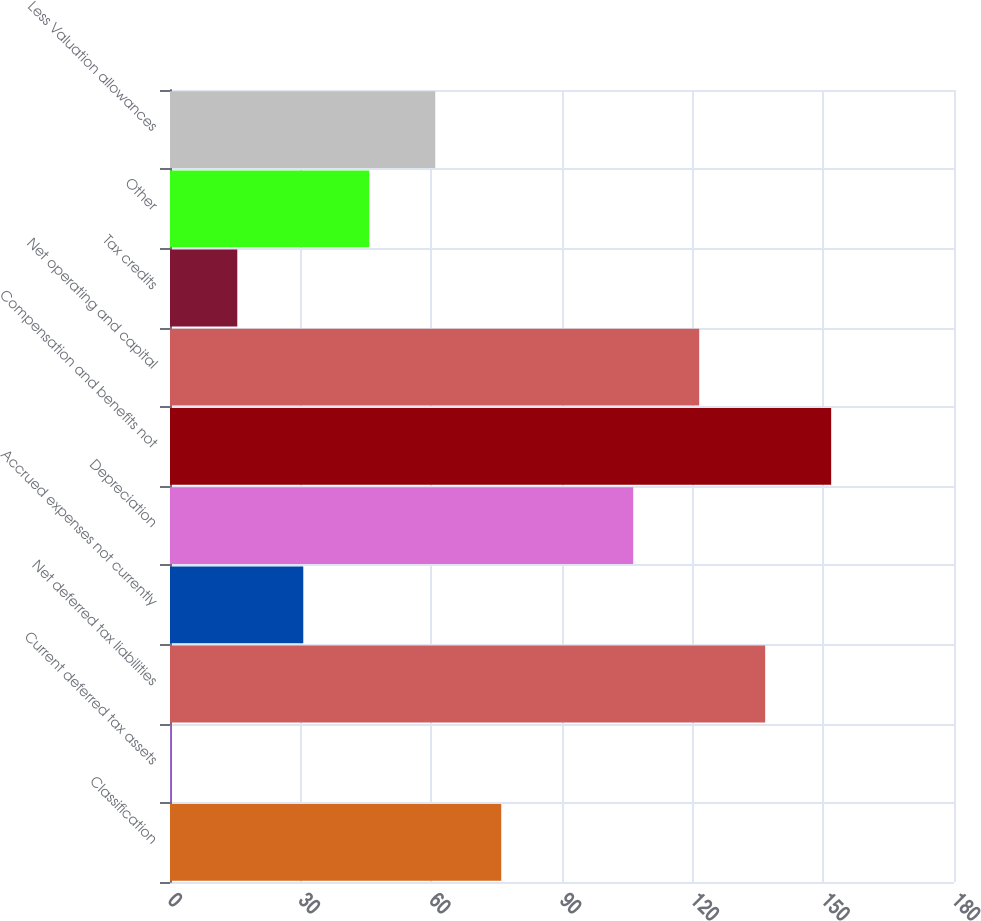Convert chart. <chart><loc_0><loc_0><loc_500><loc_500><bar_chart><fcel>Classification<fcel>Current deferred tax assets<fcel>Net deferred tax liabilities<fcel>Accrued expenses not currently<fcel>Depreciation<fcel>Compensation and benefits not<fcel>Net operating and capital<fcel>Tax credits<fcel>Other<fcel>Less Valuation allowances<nl><fcel>76.05<fcel>0.3<fcel>136.65<fcel>30.6<fcel>106.35<fcel>151.8<fcel>121.5<fcel>15.45<fcel>45.75<fcel>60.9<nl></chart> 